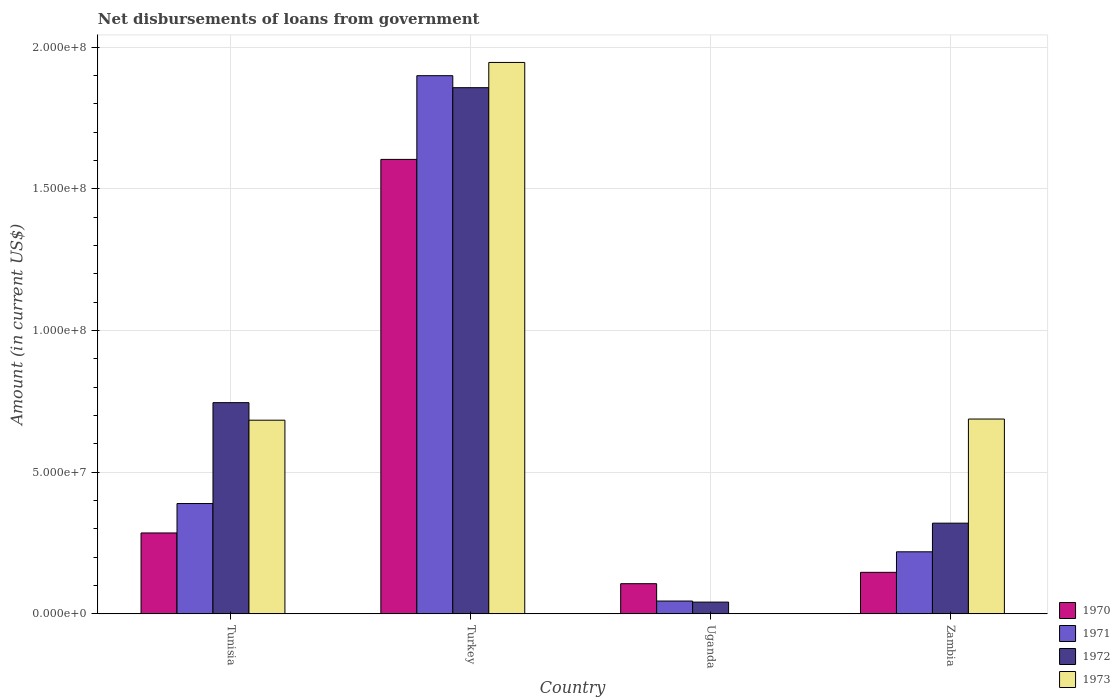How many different coloured bars are there?
Offer a terse response. 4. How many groups of bars are there?
Provide a short and direct response. 4. How many bars are there on the 2nd tick from the left?
Keep it short and to the point. 4. How many bars are there on the 1st tick from the right?
Your answer should be very brief. 4. What is the label of the 2nd group of bars from the left?
Provide a succinct answer. Turkey. In how many cases, is the number of bars for a given country not equal to the number of legend labels?
Provide a short and direct response. 1. What is the amount of loan disbursed from government in 1970 in Turkey?
Provide a succinct answer. 1.60e+08. Across all countries, what is the maximum amount of loan disbursed from government in 1973?
Your answer should be very brief. 1.95e+08. Across all countries, what is the minimum amount of loan disbursed from government in 1970?
Provide a succinct answer. 1.06e+07. What is the total amount of loan disbursed from government in 1971 in the graph?
Provide a short and direct response. 2.55e+08. What is the difference between the amount of loan disbursed from government in 1971 in Uganda and that in Zambia?
Offer a very short reply. -1.74e+07. What is the difference between the amount of loan disbursed from government in 1972 in Zambia and the amount of loan disbursed from government in 1971 in Turkey?
Keep it short and to the point. -1.58e+08. What is the average amount of loan disbursed from government in 1971 per country?
Provide a short and direct response. 6.38e+07. What is the difference between the amount of loan disbursed from government of/in 1971 and amount of loan disbursed from government of/in 1973 in Zambia?
Your answer should be very brief. -4.69e+07. What is the ratio of the amount of loan disbursed from government in 1971 in Tunisia to that in Uganda?
Keep it short and to the point. 8.64. Is the amount of loan disbursed from government in 1970 in Tunisia less than that in Turkey?
Provide a short and direct response. Yes. Is the difference between the amount of loan disbursed from government in 1971 in Turkey and Zambia greater than the difference between the amount of loan disbursed from government in 1973 in Turkey and Zambia?
Offer a terse response. Yes. What is the difference between the highest and the second highest amount of loan disbursed from government in 1970?
Provide a succinct answer. 1.46e+08. What is the difference between the highest and the lowest amount of loan disbursed from government in 1972?
Ensure brevity in your answer.  1.82e+08. How many bars are there?
Give a very brief answer. 15. Are all the bars in the graph horizontal?
Make the answer very short. No. How many countries are there in the graph?
Provide a short and direct response. 4. Where does the legend appear in the graph?
Provide a succinct answer. Bottom right. How are the legend labels stacked?
Provide a succinct answer. Vertical. What is the title of the graph?
Your answer should be compact. Net disbursements of loans from government. What is the label or title of the X-axis?
Your response must be concise. Country. What is the label or title of the Y-axis?
Your answer should be compact. Amount (in current US$). What is the Amount (in current US$) of 1970 in Tunisia?
Ensure brevity in your answer.  2.85e+07. What is the Amount (in current US$) in 1971 in Tunisia?
Give a very brief answer. 3.89e+07. What is the Amount (in current US$) of 1972 in Tunisia?
Offer a terse response. 7.45e+07. What is the Amount (in current US$) in 1973 in Tunisia?
Keep it short and to the point. 6.83e+07. What is the Amount (in current US$) of 1970 in Turkey?
Your answer should be very brief. 1.60e+08. What is the Amount (in current US$) in 1971 in Turkey?
Make the answer very short. 1.90e+08. What is the Amount (in current US$) of 1972 in Turkey?
Keep it short and to the point. 1.86e+08. What is the Amount (in current US$) in 1973 in Turkey?
Offer a terse response. 1.95e+08. What is the Amount (in current US$) in 1970 in Uganda?
Your answer should be compact. 1.06e+07. What is the Amount (in current US$) of 1971 in Uganda?
Offer a very short reply. 4.51e+06. What is the Amount (in current US$) in 1972 in Uganda?
Give a very brief answer. 4.13e+06. What is the Amount (in current US$) in 1973 in Uganda?
Your answer should be very brief. 0. What is the Amount (in current US$) in 1970 in Zambia?
Offer a very short reply. 1.46e+07. What is the Amount (in current US$) of 1971 in Zambia?
Offer a terse response. 2.19e+07. What is the Amount (in current US$) of 1972 in Zambia?
Make the answer very short. 3.20e+07. What is the Amount (in current US$) of 1973 in Zambia?
Offer a terse response. 6.88e+07. Across all countries, what is the maximum Amount (in current US$) in 1970?
Keep it short and to the point. 1.60e+08. Across all countries, what is the maximum Amount (in current US$) of 1971?
Keep it short and to the point. 1.90e+08. Across all countries, what is the maximum Amount (in current US$) of 1972?
Offer a terse response. 1.86e+08. Across all countries, what is the maximum Amount (in current US$) of 1973?
Offer a very short reply. 1.95e+08. Across all countries, what is the minimum Amount (in current US$) in 1970?
Give a very brief answer. 1.06e+07. Across all countries, what is the minimum Amount (in current US$) in 1971?
Provide a short and direct response. 4.51e+06. Across all countries, what is the minimum Amount (in current US$) of 1972?
Give a very brief answer. 4.13e+06. What is the total Amount (in current US$) in 1970 in the graph?
Make the answer very short. 2.14e+08. What is the total Amount (in current US$) of 1971 in the graph?
Provide a succinct answer. 2.55e+08. What is the total Amount (in current US$) of 1972 in the graph?
Offer a very short reply. 2.96e+08. What is the total Amount (in current US$) of 1973 in the graph?
Make the answer very short. 3.32e+08. What is the difference between the Amount (in current US$) in 1970 in Tunisia and that in Turkey?
Ensure brevity in your answer.  -1.32e+08. What is the difference between the Amount (in current US$) in 1971 in Tunisia and that in Turkey?
Your response must be concise. -1.51e+08. What is the difference between the Amount (in current US$) of 1972 in Tunisia and that in Turkey?
Keep it short and to the point. -1.11e+08. What is the difference between the Amount (in current US$) of 1973 in Tunisia and that in Turkey?
Offer a very short reply. -1.26e+08. What is the difference between the Amount (in current US$) of 1970 in Tunisia and that in Uganda?
Your answer should be compact. 1.79e+07. What is the difference between the Amount (in current US$) in 1971 in Tunisia and that in Uganda?
Offer a very short reply. 3.44e+07. What is the difference between the Amount (in current US$) of 1972 in Tunisia and that in Uganda?
Keep it short and to the point. 7.04e+07. What is the difference between the Amount (in current US$) of 1970 in Tunisia and that in Zambia?
Give a very brief answer. 1.39e+07. What is the difference between the Amount (in current US$) in 1971 in Tunisia and that in Zambia?
Provide a succinct answer. 1.70e+07. What is the difference between the Amount (in current US$) in 1972 in Tunisia and that in Zambia?
Give a very brief answer. 4.25e+07. What is the difference between the Amount (in current US$) in 1973 in Tunisia and that in Zambia?
Keep it short and to the point. -4.12e+05. What is the difference between the Amount (in current US$) of 1970 in Turkey and that in Uganda?
Give a very brief answer. 1.50e+08. What is the difference between the Amount (in current US$) in 1971 in Turkey and that in Uganda?
Provide a short and direct response. 1.85e+08. What is the difference between the Amount (in current US$) of 1972 in Turkey and that in Uganda?
Your answer should be very brief. 1.82e+08. What is the difference between the Amount (in current US$) of 1970 in Turkey and that in Zambia?
Give a very brief answer. 1.46e+08. What is the difference between the Amount (in current US$) of 1971 in Turkey and that in Zambia?
Keep it short and to the point. 1.68e+08. What is the difference between the Amount (in current US$) of 1972 in Turkey and that in Zambia?
Provide a short and direct response. 1.54e+08. What is the difference between the Amount (in current US$) of 1973 in Turkey and that in Zambia?
Your response must be concise. 1.26e+08. What is the difference between the Amount (in current US$) of 1970 in Uganda and that in Zambia?
Provide a short and direct response. -4.01e+06. What is the difference between the Amount (in current US$) in 1971 in Uganda and that in Zambia?
Make the answer very short. -1.74e+07. What is the difference between the Amount (in current US$) in 1972 in Uganda and that in Zambia?
Offer a terse response. -2.79e+07. What is the difference between the Amount (in current US$) of 1970 in Tunisia and the Amount (in current US$) of 1971 in Turkey?
Your response must be concise. -1.61e+08. What is the difference between the Amount (in current US$) in 1970 in Tunisia and the Amount (in current US$) in 1972 in Turkey?
Give a very brief answer. -1.57e+08. What is the difference between the Amount (in current US$) of 1970 in Tunisia and the Amount (in current US$) of 1973 in Turkey?
Your answer should be very brief. -1.66e+08. What is the difference between the Amount (in current US$) in 1971 in Tunisia and the Amount (in current US$) in 1972 in Turkey?
Provide a succinct answer. -1.47e+08. What is the difference between the Amount (in current US$) of 1971 in Tunisia and the Amount (in current US$) of 1973 in Turkey?
Give a very brief answer. -1.56e+08. What is the difference between the Amount (in current US$) of 1972 in Tunisia and the Amount (in current US$) of 1973 in Turkey?
Offer a terse response. -1.20e+08. What is the difference between the Amount (in current US$) of 1970 in Tunisia and the Amount (in current US$) of 1971 in Uganda?
Offer a terse response. 2.40e+07. What is the difference between the Amount (in current US$) of 1970 in Tunisia and the Amount (in current US$) of 1972 in Uganda?
Provide a succinct answer. 2.44e+07. What is the difference between the Amount (in current US$) of 1971 in Tunisia and the Amount (in current US$) of 1972 in Uganda?
Your response must be concise. 3.48e+07. What is the difference between the Amount (in current US$) of 1970 in Tunisia and the Amount (in current US$) of 1971 in Zambia?
Ensure brevity in your answer.  6.66e+06. What is the difference between the Amount (in current US$) of 1970 in Tunisia and the Amount (in current US$) of 1972 in Zambia?
Your answer should be compact. -3.46e+06. What is the difference between the Amount (in current US$) in 1970 in Tunisia and the Amount (in current US$) in 1973 in Zambia?
Your answer should be very brief. -4.02e+07. What is the difference between the Amount (in current US$) in 1971 in Tunisia and the Amount (in current US$) in 1972 in Zambia?
Keep it short and to the point. 6.92e+06. What is the difference between the Amount (in current US$) of 1971 in Tunisia and the Amount (in current US$) of 1973 in Zambia?
Offer a terse response. -2.98e+07. What is the difference between the Amount (in current US$) of 1972 in Tunisia and the Amount (in current US$) of 1973 in Zambia?
Offer a terse response. 5.78e+06. What is the difference between the Amount (in current US$) in 1970 in Turkey and the Amount (in current US$) in 1971 in Uganda?
Make the answer very short. 1.56e+08. What is the difference between the Amount (in current US$) in 1970 in Turkey and the Amount (in current US$) in 1972 in Uganda?
Provide a succinct answer. 1.56e+08. What is the difference between the Amount (in current US$) of 1971 in Turkey and the Amount (in current US$) of 1972 in Uganda?
Give a very brief answer. 1.86e+08. What is the difference between the Amount (in current US$) in 1970 in Turkey and the Amount (in current US$) in 1971 in Zambia?
Your answer should be compact. 1.39e+08. What is the difference between the Amount (in current US$) in 1970 in Turkey and the Amount (in current US$) in 1972 in Zambia?
Offer a very short reply. 1.28e+08. What is the difference between the Amount (in current US$) in 1970 in Turkey and the Amount (in current US$) in 1973 in Zambia?
Offer a terse response. 9.16e+07. What is the difference between the Amount (in current US$) in 1971 in Turkey and the Amount (in current US$) in 1972 in Zambia?
Provide a short and direct response. 1.58e+08. What is the difference between the Amount (in current US$) of 1971 in Turkey and the Amount (in current US$) of 1973 in Zambia?
Offer a very short reply. 1.21e+08. What is the difference between the Amount (in current US$) in 1972 in Turkey and the Amount (in current US$) in 1973 in Zambia?
Your answer should be compact. 1.17e+08. What is the difference between the Amount (in current US$) of 1970 in Uganda and the Amount (in current US$) of 1971 in Zambia?
Make the answer very short. -1.13e+07. What is the difference between the Amount (in current US$) of 1970 in Uganda and the Amount (in current US$) of 1972 in Zambia?
Your response must be concise. -2.14e+07. What is the difference between the Amount (in current US$) in 1970 in Uganda and the Amount (in current US$) in 1973 in Zambia?
Provide a succinct answer. -5.81e+07. What is the difference between the Amount (in current US$) of 1971 in Uganda and the Amount (in current US$) of 1972 in Zambia?
Your response must be concise. -2.75e+07. What is the difference between the Amount (in current US$) in 1971 in Uganda and the Amount (in current US$) in 1973 in Zambia?
Provide a succinct answer. -6.42e+07. What is the difference between the Amount (in current US$) of 1972 in Uganda and the Amount (in current US$) of 1973 in Zambia?
Give a very brief answer. -6.46e+07. What is the average Amount (in current US$) in 1970 per country?
Provide a succinct answer. 5.35e+07. What is the average Amount (in current US$) of 1971 per country?
Give a very brief answer. 6.38e+07. What is the average Amount (in current US$) in 1972 per country?
Offer a very short reply. 7.41e+07. What is the average Amount (in current US$) in 1973 per country?
Make the answer very short. 8.29e+07. What is the difference between the Amount (in current US$) in 1970 and Amount (in current US$) in 1971 in Tunisia?
Make the answer very short. -1.04e+07. What is the difference between the Amount (in current US$) of 1970 and Amount (in current US$) of 1972 in Tunisia?
Keep it short and to the point. -4.60e+07. What is the difference between the Amount (in current US$) of 1970 and Amount (in current US$) of 1973 in Tunisia?
Offer a terse response. -3.98e+07. What is the difference between the Amount (in current US$) of 1971 and Amount (in current US$) of 1972 in Tunisia?
Ensure brevity in your answer.  -3.56e+07. What is the difference between the Amount (in current US$) of 1971 and Amount (in current US$) of 1973 in Tunisia?
Your response must be concise. -2.94e+07. What is the difference between the Amount (in current US$) in 1972 and Amount (in current US$) in 1973 in Tunisia?
Give a very brief answer. 6.20e+06. What is the difference between the Amount (in current US$) of 1970 and Amount (in current US$) of 1971 in Turkey?
Keep it short and to the point. -2.95e+07. What is the difference between the Amount (in current US$) in 1970 and Amount (in current US$) in 1972 in Turkey?
Ensure brevity in your answer.  -2.53e+07. What is the difference between the Amount (in current US$) of 1970 and Amount (in current US$) of 1973 in Turkey?
Your answer should be compact. -3.42e+07. What is the difference between the Amount (in current US$) in 1971 and Amount (in current US$) in 1972 in Turkey?
Offer a terse response. 4.24e+06. What is the difference between the Amount (in current US$) in 1971 and Amount (in current US$) in 1973 in Turkey?
Offer a terse response. -4.67e+06. What is the difference between the Amount (in current US$) of 1972 and Amount (in current US$) of 1973 in Turkey?
Provide a short and direct response. -8.91e+06. What is the difference between the Amount (in current US$) in 1970 and Amount (in current US$) in 1971 in Uganda?
Give a very brief answer. 6.12e+06. What is the difference between the Amount (in current US$) in 1970 and Amount (in current US$) in 1972 in Uganda?
Offer a very short reply. 6.50e+06. What is the difference between the Amount (in current US$) of 1971 and Amount (in current US$) of 1972 in Uganda?
Your answer should be compact. 3.77e+05. What is the difference between the Amount (in current US$) in 1970 and Amount (in current US$) in 1971 in Zambia?
Offer a terse response. -7.25e+06. What is the difference between the Amount (in current US$) of 1970 and Amount (in current US$) of 1972 in Zambia?
Give a very brief answer. -1.74e+07. What is the difference between the Amount (in current US$) of 1970 and Amount (in current US$) of 1973 in Zambia?
Offer a very short reply. -5.41e+07. What is the difference between the Amount (in current US$) of 1971 and Amount (in current US$) of 1972 in Zambia?
Offer a terse response. -1.01e+07. What is the difference between the Amount (in current US$) of 1971 and Amount (in current US$) of 1973 in Zambia?
Your answer should be very brief. -4.69e+07. What is the difference between the Amount (in current US$) in 1972 and Amount (in current US$) in 1973 in Zambia?
Your answer should be compact. -3.68e+07. What is the ratio of the Amount (in current US$) of 1970 in Tunisia to that in Turkey?
Give a very brief answer. 0.18. What is the ratio of the Amount (in current US$) in 1971 in Tunisia to that in Turkey?
Your answer should be compact. 0.2. What is the ratio of the Amount (in current US$) in 1972 in Tunisia to that in Turkey?
Offer a very short reply. 0.4. What is the ratio of the Amount (in current US$) of 1973 in Tunisia to that in Turkey?
Provide a succinct answer. 0.35. What is the ratio of the Amount (in current US$) in 1970 in Tunisia to that in Uganda?
Give a very brief answer. 2.68. What is the ratio of the Amount (in current US$) in 1971 in Tunisia to that in Uganda?
Provide a short and direct response. 8.64. What is the ratio of the Amount (in current US$) of 1972 in Tunisia to that in Uganda?
Your answer should be compact. 18.05. What is the ratio of the Amount (in current US$) in 1970 in Tunisia to that in Zambia?
Keep it short and to the point. 1.95. What is the ratio of the Amount (in current US$) of 1971 in Tunisia to that in Zambia?
Make the answer very short. 1.78. What is the ratio of the Amount (in current US$) in 1972 in Tunisia to that in Zambia?
Provide a succinct answer. 2.33. What is the ratio of the Amount (in current US$) in 1970 in Turkey to that in Uganda?
Ensure brevity in your answer.  15.09. What is the ratio of the Amount (in current US$) of 1971 in Turkey to that in Uganda?
Provide a succinct answer. 42.14. What is the ratio of the Amount (in current US$) of 1972 in Turkey to that in Uganda?
Offer a terse response. 44.97. What is the ratio of the Amount (in current US$) in 1970 in Turkey to that in Zambia?
Make the answer very short. 10.96. What is the ratio of the Amount (in current US$) of 1971 in Turkey to that in Zambia?
Ensure brevity in your answer.  8.68. What is the ratio of the Amount (in current US$) of 1972 in Turkey to that in Zambia?
Provide a succinct answer. 5.8. What is the ratio of the Amount (in current US$) in 1973 in Turkey to that in Zambia?
Your answer should be compact. 2.83. What is the ratio of the Amount (in current US$) in 1970 in Uganda to that in Zambia?
Provide a succinct answer. 0.73. What is the ratio of the Amount (in current US$) in 1971 in Uganda to that in Zambia?
Offer a terse response. 0.21. What is the ratio of the Amount (in current US$) in 1972 in Uganda to that in Zambia?
Ensure brevity in your answer.  0.13. What is the difference between the highest and the second highest Amount (in current US$) of 1970?
Offer a very short reply. 1.32e+08. What is the difference between the highest and the second highest Amount (in current US$) in 1971?
Keep it short and to the point. 1.51e+08. What is the difference between the highest and the second highest Amount (in current US$) of 1972?
Offer a terse response. 1.11e+08. What is the difference between the highest and the second highest Amount (in current US$) in 1973?
Offer a very short reply. 1.26e+08. What is the difference between the highest and the lowest Amount (in current US$) in 1970?
Give a very brief answer. 1.50e+08. What is the difference between the highest and the lowest Amount (in current US$) of 1971?
Offer a very short reply. 1.85e+08. What is the difference between the highest and the lowest Amount (in current US$) of 1972?
Your response must be concise. 1.82e+08. What is the difference between the highest and the lowest Amount (in current US$) in 1973?
Offer a very short reply. 1.95e+08. 